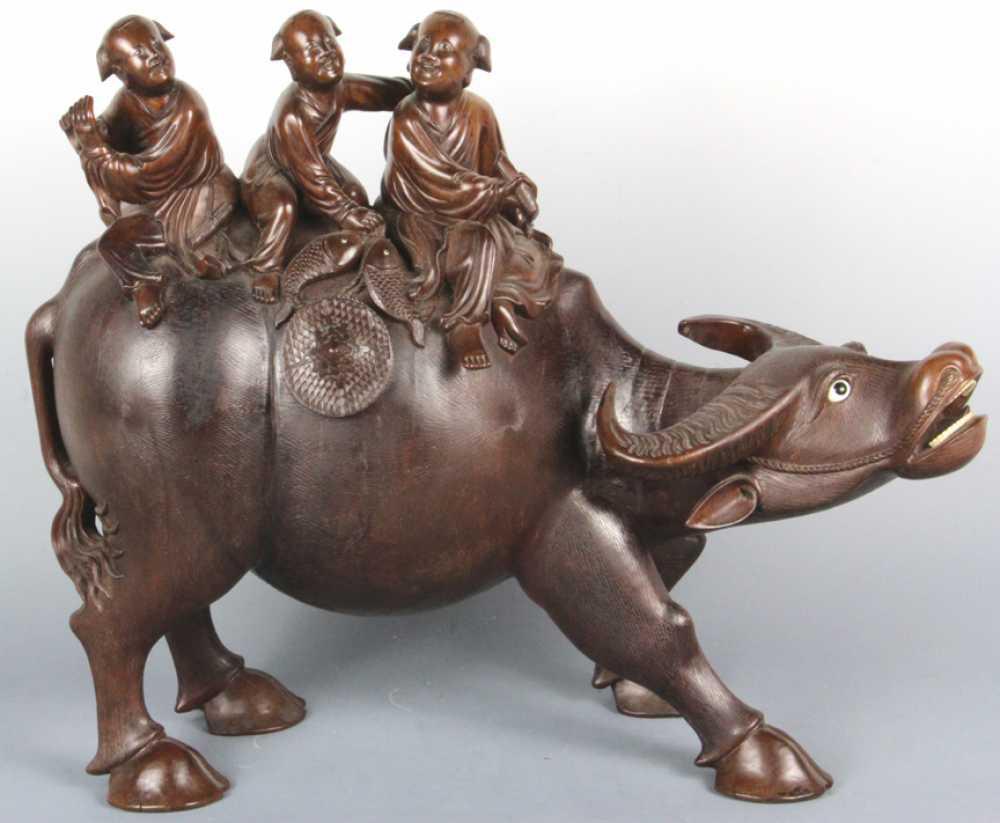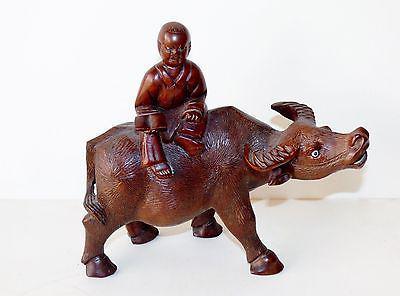The first image is the image on the left, the second image is the image on the right. For the images displayed, is the sentence "Each image shows at least one figure on the back of a water buffalo with its head extending forward so its horns are parallel with the ground." factually correct? Answer yes or no. Yes. 